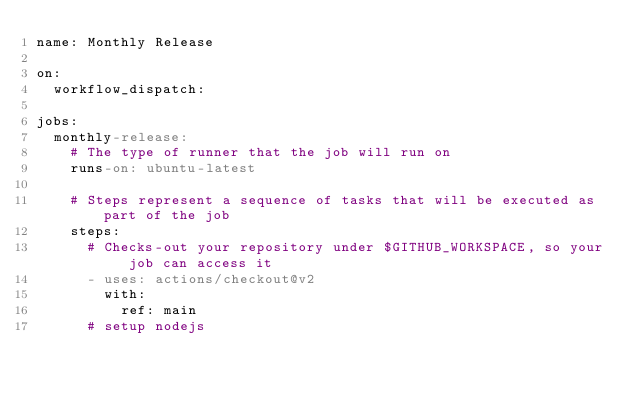Convert code to text. <code><loc_0><loc_0><loc_500><loc_500><_YAML_>name: Monthly Release

on:
  workflow_dispatch:

jobs:
  monthly-release:
    # The type of runner that the job will run on
    runs-on: ubuntu-latest

    # Steps represent a sequence of tasks that will be executed as part of the job
    steps:
      # Checks-out your repository under $GITHUB_WORKSPACE, so your job can access it
      - uses: actions/checkout@v2
        with:
          ref: main    
      # setup nodejs</code> 